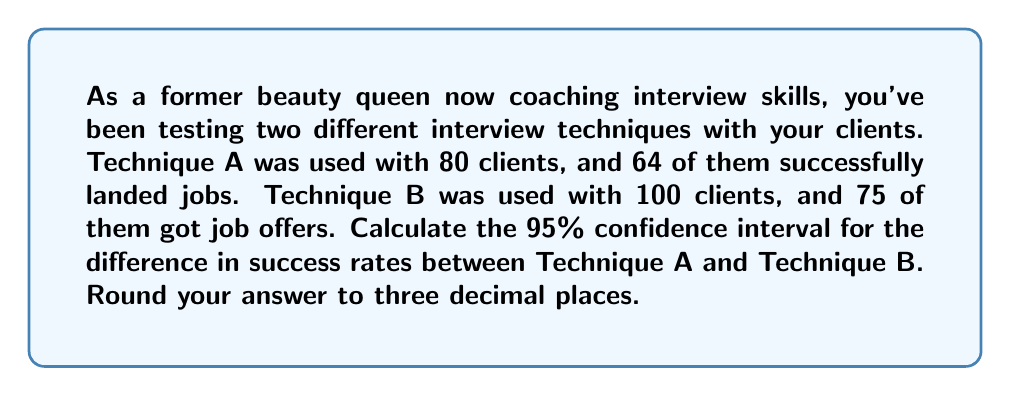Teach me how to tackle this problem. Let's approach this step-by-step:

1) First, calculate the success rates for each technique:
   Technique A: $p_A = 64/80 = 0.8$
   Technique B: $p_B = 75/100 = 0.75$

2) The difference in success rates is:
   $p_A - p_B = 0.8 - 0.75 = 0.05$

3) For a 95% confidence interval, we use $z = 1.96$

4) The standard error of the difference is:
   $$SE = \sqrt{\frac{p_A(1-p_A)}{n_A} + \frac{p_B(1-p_B)}{n_B}}$$
   $$SE = \sqrt{\frac{0.8(0.2)}{80} + \frac{0.75(0.25)}{100}}$$
   $$SE = \sqrt{0.002 + 0.001875} = \sqrt{0.003875} = 0.0622$$

5) The confidence interval is calculated as:
   $$(p_A - p_B) \pm z \cdot SE$$
   $$0.05 \pm 1.96 \cdot 0.0622$$

6) Calculating the bounds:
   Lower bound: $0.05 - (1.96 \cdot 0.0622) = -0.072$
   Upper bound: $0.05 + (1.96 \cdot 0.0622) = 0.172$

7) Rounding to three decimal places:
   (-0.072, 0.172)
Answer: (-0.072, 0.172) 